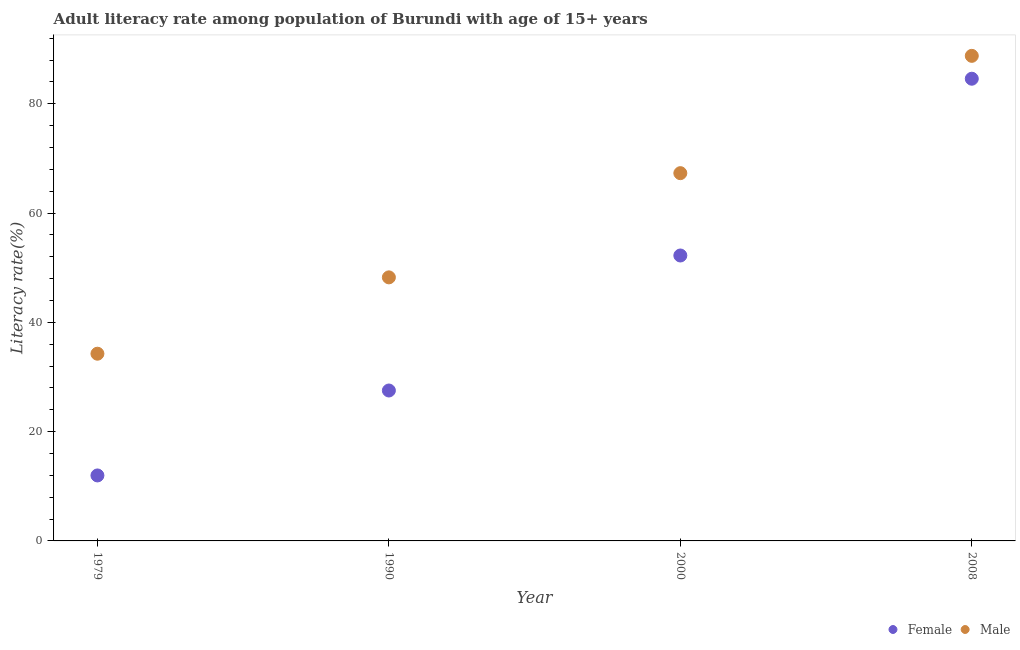What is the female adult literacy rate in 1979?
Ensure brevity in your answer.  11.98. Across all years, what is the maximum male adult literacy rate?
Offer a very short reply. 88.78. Across all years, what is the minimum female adult literacy rate?
Provide a succinct answer. 11.98. In which year was the female adult literacy rate maximum?
Provide a succinct answer. 2008. In which year was the female adult literacy rate minimum?
Your answer should be very brief. 1979. What is the total male adult literacy rate in the graph?
Make the answer very short. 238.58. What is the difference between the female adult literacy rate in 1990 and that in 2008?
Provide a short and direct response. -57.06. What is the difference between the male adult literacy rate in 2000 and the female adult literacy rate in 2008?
Your answer should be compact. -17.28. What is the average female adult literacy rate per year?
Keep it short and to the point. 44.09. In the year 1979, what is the difference between the female adult literacy rate and male adult literacy rate?
Your answer should be compact. -22.28. In how many years, is the male adult literacy rate greater than 84 %?
Ensure brevity in your answer.  1. What is the ratio of the male adult literacy rate in 1990 to that in 2008?
Your answer should be compact. 0.54. Is the male adult literacy rate in 1979 less than that in 2008?
Provide a succinct answer. Yes. What is the difference between the highest and the second highest male adult literacy rate?
Your answer should be compact. 21.47. What is the difference between the highest and the lowest male adult literacy rate?
Your answer should be compact. 54.51. Is the sum of the female adult literacy rate in 1979 and 2000 greater than the maximum male adult literacy rate across all years?
Ensure brevity in your answer.  No. Does the female adult literacy rate monotonically increase over the years?
Offer a very short reply. Yes. What is the title of the graph?
Your response must be concise. Adult literacy rate among population of Burundi with age of 15+ years. What is the label or title of the Y-axis?
Your answer should be compact. Literacy rate(%). What is the Literacy rate(%) of Female in 1979?
Give a very brief answer. 11.98. What is the Literacy rate(%) in Male in 1979?
Keep it short and to the point. 34.26. What is the Literacy rate(%) of Female in 1990?
Keep it short and to the point. 27.53. What is the Literacy rate(%) of Male in 1990?
Your answer should be compact. 48.24. What is the Literacy rate(%) in Female in 2000?
Keep it short and to the point. 52.24. What is the Literacy rate(%) in Male in 2000?
Provide a succinct answer. 67.31. What is the Literacy rate(%) in Female in 2008?
Your response must be concise. 84.59. What is the Literacy rate(%) of Male in 2008?
Your answer should be compact. 88.78. Across all years, what is the maximum Literacy rate(%) in Female?
Your answer should be very brief. 84.59. Across all years, what is the maximum Literacy rate(%) of Male?
Make the answer very short. 88.78. Across all years, what is the minimum Literacy rate(%) in Female?
Your response must be concise. 11.98. Across all years, what is the minimum Literacy rate(%) of Male?
Your answer should be very brief. 34.26. What is the total Literacy rate(%) of Female in the graph?
Your answer should be compact. 176.34. What is the total Literacy rate(%) in Male in the graph?
Keep it short and to the point. 238.58. What is the difference between the Literacy rate(%) in Female in 1979 and that in 1990?
Give a very brief answer. -15.55. What is the difference between the Literacy rate(%) of Male in 1979 and that in 1990?
Keep it short and to the point. -13.97. What is the difference between the Literacy rate(%) of Female in 1979 and that in 2000?
Your answer should be very brief. -40.25. What is the difference between the Literacy rate(%) in Male in 1979 and that in 2000?
Make the answer very short. -33.04. What is the difference between the Literacy rate(%) of Female in 1979 and that in 2008?
Your response must be concise. -72.61. What is the difference between the Literacy rate(%) of Male in 1979 and that in 2008?
Offer a terse response. -54.51. What is the difference between the Literacy rate(%) in Female in 1990 and that in 2000?
Offer a very short reply. -24.71. What is the difference between the Literacy rate(%) in Male in 1990 and that in 2000?
Your response must be concise. -19.07. What is the difference between the Literacy rate(%) of Female in 1990 and that in 2008?
Offer a very short reply. -57.06. What is the difference between the Literacy rate(%) in Male in 1990 and that in 2008?
Keep it short and to the point. -40.54. What is the difference between the Literacy rate(%) of Female in 2000 and that in 2008?
Offer a terse response. -32.35. What is the difference between the Literacy rate(%) in Male in 2000 and that in 2008?
Provide a succinct answer. -21.47. What is the difference between the Literacy rate(%) in Female in 1979 and the Literacy rate(%) in Male in 1990?
Offer a very short reply. -36.25. What is the difference between the Literacy rate(%) of Female in 1979 and the Literacy rate(%) of Male in 2000?
Offer a terse response. -55.32. What is the difference between the Literacy rate(%) in Female in 1979 and the Literacy rate(%) in Male in 2008?
Your answer should be very brief. -76.79. What is the difference between the Literacy rate(%) in Female in 1990 and the Literacy rate(%) in Male in 2000?
Your answer should be very brief. -39.78. What is the difference between the Literacy rate(%) in Female in 1990 and the Literacy rate(%) in Male in 2008?
Offer a terse response. -61.25. What is the difference between the Literacy rate(%) of Female in 2000 and the Literacy rate(%) of Male in 2008?
Provide a succinct answer. -36.54. What is the average Literacy rate(%) of Female per year?
Your response must be concise. 44.09. What is the average Literacy rate(%) in Male per year?
Give a very brief answer. 59.65. In the year 1979, what is the difference between the Literacy rate(%) in Female and Literacy rate(%) in Male?
Give a very brief answer. -22.28. In the year 1990, what is the difference between the Literacy rate(%) in Female and Literacy rate(%) in Male?
Make the answer very short. -20.71. In the year 2000, what is the difference between the Literacy rate(%) in Female and Literacy rate(%) in Male?
Provide a succinct answer. -15.07. In the year 2008, what is the difference between the Literacy rate(%) in Female and Literacy rate(%) in Male?
Your answer should be very brief. -4.18. What is the ratio of the Literacy rate(%) of Female in 1979 to that in 1990?
Provide a succinct answer. 0.44. What is the ratio of the Literacy rate(%) of Male in 1979 to that in 1990?
Provide a short and direct response. 0.71. What is the ratio of the Literacy rate(%) in Female in 1979 to that in 2000?
Give a very brief answer. 0.23. What is the ratio of the Literacy rate(%) of Male in 1979 to that in 2000?
Provide a short and direct response. 0.51. What is the ratio of the Literacy rate(%) of Female in 1979 to that in 2008?
Offer a terse response. 0.14. What is the ratio of the Literacy rate(%) of Male in 1979 to that in 2008?
Give a very brief answer. 0.39. What is the ratio of the Literacy rate(%) in Female in 1990 to that in 2000?
Offer a terse response. 0.53. What is the ratio of the Literacy rate(%) in Male in 1990 to that in 2000?
Keep it short and to the point. 0.72. What is the ratio of the Literacy rate(%) in Female in 1990 to that in 2008?
Provide a succinct answer. 0.33. What is the ratio of the Literacy rate(%) of Male in 1990 to that in 2008?
Your answer should be compact. 0.54. What is the ratio of the Literacy rate(%) in Female in 2000 to that in 2008?
Give a very brief answer. 0.62. What is the ratio of the Literacy rate(%) in Male in 2000 to that in 2008?
Provide a short and direct response. 0.76. What is the difference between the highest and the second highest Literacy rate(%) in Female?
Make the answer very short. 32.35. What is the difference between the highest and the second highest Literacy rate(%) of Male?
Give a very brief answer. 21.47. What is the difference between the highest and the lowest Literacy rate(%) of Female?
Give a very brief answer. 72.61. What is the difference between the highest and the lowest Literacy rate(%) in Male?
Your answer should be very brief. 54.51. 